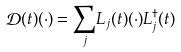Convert formula to latex. <formula><loc_0><loc_0><loc_500><loc_500>\mathcal { D } ( t ) ( \cdot ) = \underset { j } { \sum } L _ { j } ( t ) ( \cdot ) L _ { j } ^ { \dagger } ( t )</formula> 